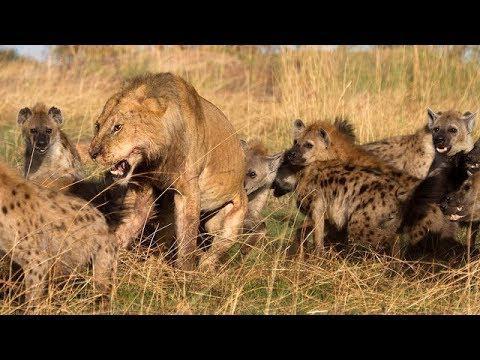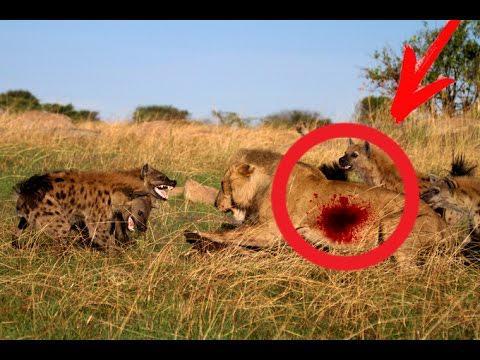The first image is the image on the left, the second image is the image on the right. Given the left and right images, does the statement "A lion is bleeding in one of the images." hold true? Answer yes or no. Yes. The first image is the image on the left, the second image is the image on the right. Evaluate the accuracy of this statement regarding the images: "An image shows many 'smiling' hyenas with upraised heads around a carcass with ribs showing.". Is it true? Answer yes or no. No. 